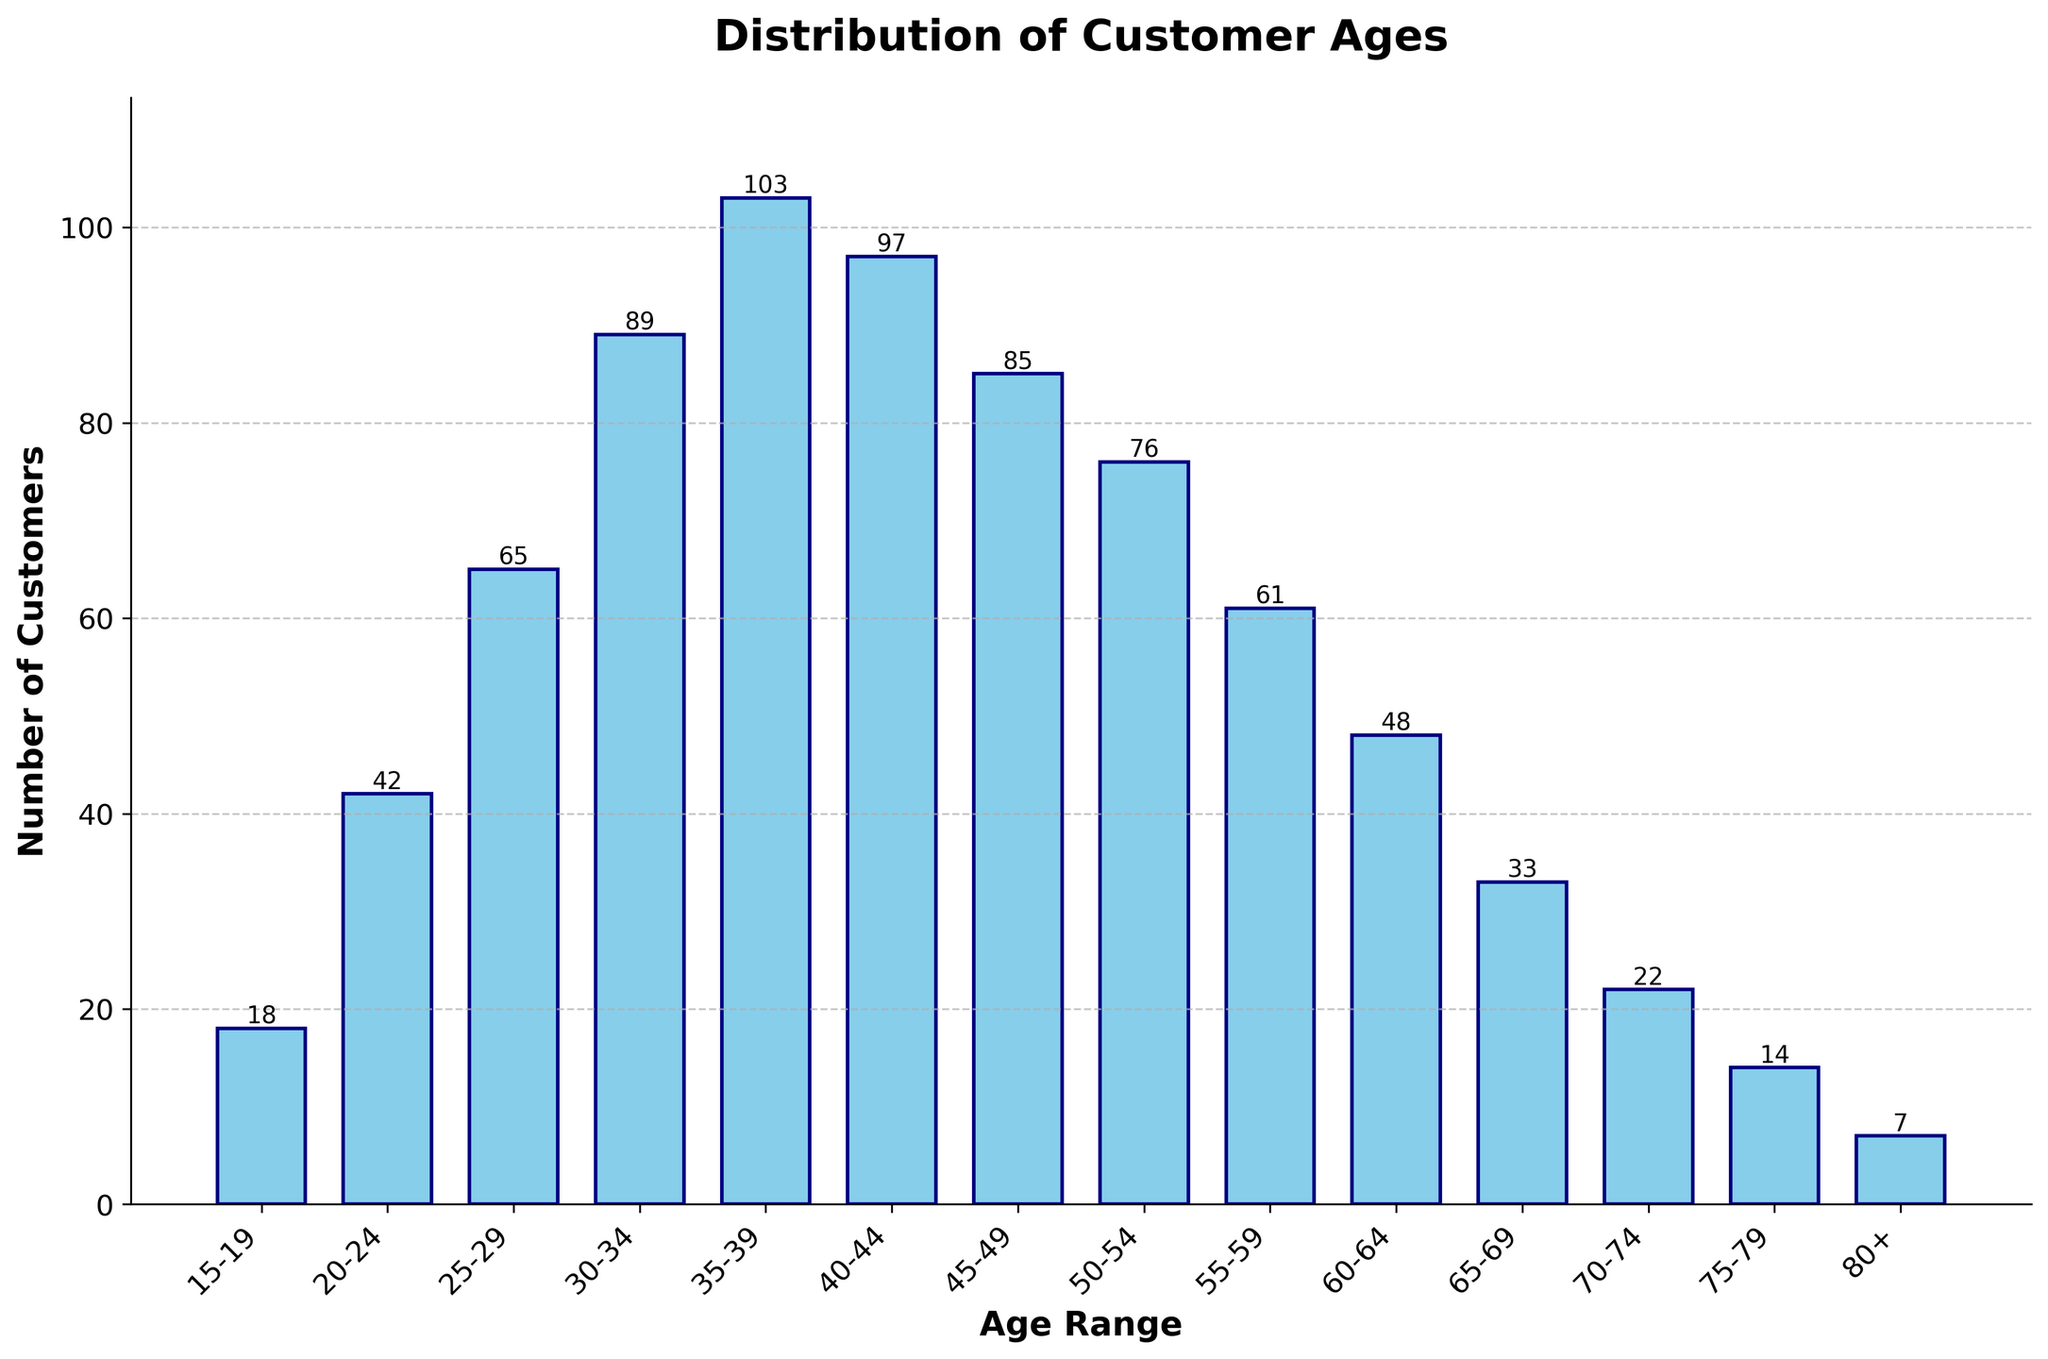What is the title of the figure? The title of the figure is displayed at the top of the chart. By referring to the chart, you can easily read the title.
Answer: Distribution of Customer Ages What is the range with the highest number of customers? The highest bar in the histogram indicates the range with the most customers. In this chart, it is the range 35-39.
Answer: 35-39 How many customers are aged between 45-49? To find the number of customers in this age range, look at the height of the bar labeled 45-49. The value should be annotated on top of the bar for clarity.
Answer: 85 What is the combined total number of customers for the age ranges 30-34 and 35-39? To find the combined total, sum the number of customers for the age ranges 30-34 and 35-39. So, 89 (30-34) + 103 (35-39) = 192.
Answer: 192 Which age range has fewer customers: 60-64 or 65-69? Compare the heights of the bars for 60-64 and 65-69. The 65-69 range has a shorter bar.
Answer: 65-69 What is the average number of customers for the age ranges from 20-24 to 30-34? Add the number of customers for the age ranges 20-24, 25-29, and 30-34, then divide by 3. So, (42 + 65 + 89) / 3 = 65.33.
Answer: 65.33 Are there more customers in the 75-79 age range or the 15-19 age range? Compare the heights of the bars for 75-79 and 15-19. The 15-19 range has a taller bar.
Answer: 15-19 What is the difference in the number of customers between the age ranges 50-54 and 55-59? Subtract the number of customers for 55-59 from the number of customers for 50-54. So, 76 (50-54) - 61 (55-59) = 15.
Answer: 15 Is the number of customers generally increasing, decreasing, or staying constant with age? Observing the trend of the bar heights as the age increases shows that initially the number increases, peaks, then decreases steadily.
Answer: Initially increasing, then decreasing How many more customers are there in the age range 30-34 compared to 25-29? Subtract the number of customers in 25-29 from the number in 30-34. So, 89 (30-34) - 65 (25-29) = 24.
Answer: 24 